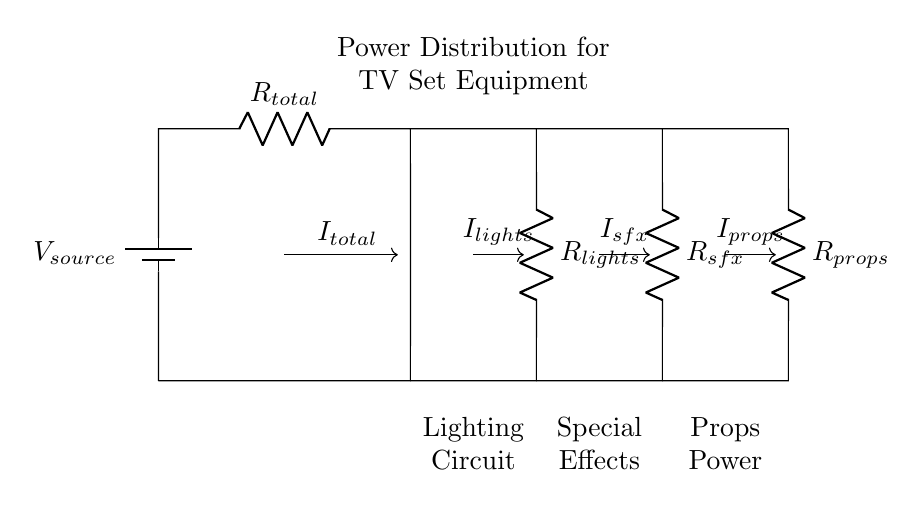What is the source voltage in this circuit? The source voltage is labeled as V source, which is the voltage provided to the entire circuit.
Answer: V source What are the three loaded components in the circuit? The loaded components are labeled as R lights, R sfx, and R props, which represent the loads for lights, special effects, and props, respectively.
Answer: R lights, R sfx, R props How many total resistors are present in this circuit layout? There are a total of four resistors: one for the total resistance and three for the individual loads (lights, special effects, and props).
Answer: Four What is the relationship between total current and individual currents in a current divider? In a current divider, the total current is equal to the sum of the individual currents for each branch. The currents divide among the branches based on their resistances.
Answer: I total = I lights + I sfx + I props If the resistance R props is increased, what happens to the current I props? If R props increases, the current I props decreases, as a higher resistance causes less current to flow through that branch in accordance with Ohm's Law.
Answer: Decreases Which component represents the combined load of lights and special effects? The combined load of lights and special effects is represented by R lights and R sfx, but they are distinct components in the circuit and not combined into a single element.
Answer: R lights, R sfx 